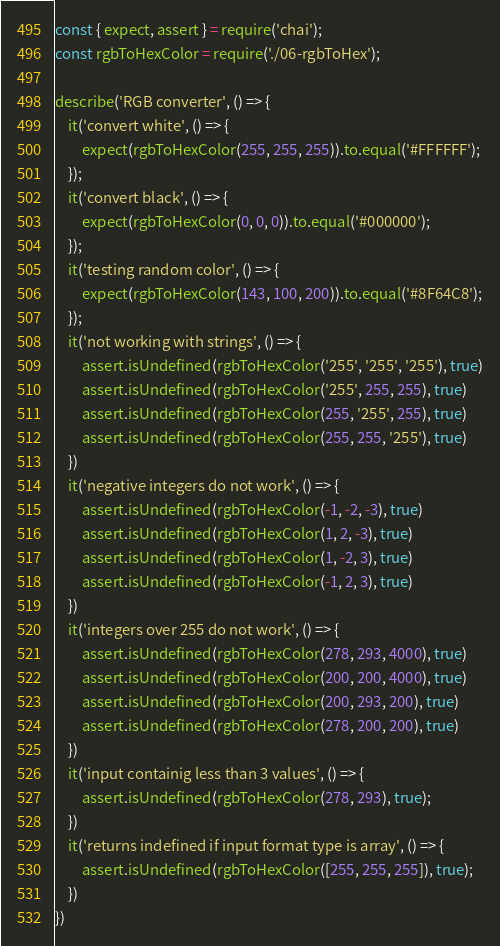Convert code to text. <code><loc_0><loc_0><loc_500><loc_500><_JavaScript_>const { expect, assert } = require('chai');
const rgbToHexColor = require('./06-rgbToHex');

describe('RGB converter', () => {
    it('convert white', () => {
        expect(rgbToHexColor(255, 255, 255)).to.equal('#FFFFFF');
    });
    it('convert black', () => {
        expect(rgbToHexColor(0, 0, 0)).to.equal('#000000');
    });
    it('testing random color', () => {
        expect(rgbToHexColor(143, 100, 200)).to.equal('#8F64C8');
    });
    it('not working with strings', () => {
        assert.isUndefined(rgbToHexColor('255', '255', '255'), true)
        assert.isUndefined(rgbToHexColor('255', 255, 255), true)
        assert.isUndefined(rgbToHexColor(255, '255', 255), true)
        assert.isUndefined(rgbToHexColor(255, 255, '255'), true)
    })
    it('negative integers do not work', () => {
        assert.isUndefined(rgbToHexColor(-1, -2, -3), true)
        assert.isUndefined(rgbToHexColor(1, 2, -3), true)
        assert.isUndefined(rgbToHexColor(1, -2, 3), true)
        assert.isUndefined(rgbToHexColor(-1, 2, 3), true)
    })
    it('integers over 255 do not work', () => {
        assert.isUndefined(rgbToHexColor(278, 293, 4000), true)
        assert.isUndefined(rgbToHexColor(200, 200, 4000), true)
        assert.isUndefined(rgbToHexColor(200, 293, 200), true)
        assert.isUndefined(rgbToHexColor(278, 200, 200), true)
    })
    it('input containig less than 3 values', () => {
        assert.isUndefined(rgbToHexColor(278, 293), true);
    })
    it('returns indefined if input format type is array', () => {
        assert.isUndefined(rgbToHexColor([255, 255, 255]), true);
    })
})</code> 